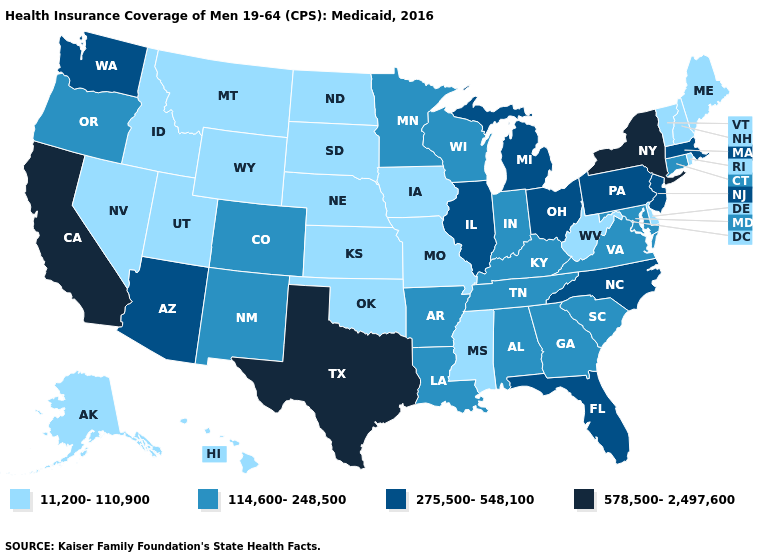What is the highest value in the USA?
Concise answer only. 578,500-2,497,600. Name the states that have a value in the range 11,200-110,900?
Answer briefly. Alaska, Delaware, Hawaii, Idaho, Iowa, Kansas, Maine, Mississippi, Missouri, Montana, Nebraska, Nevada, New Hampshire, North Dakota, Oklahoma, Rhode Island, South Dakota, Utah, Vermont, West Virginia, Wyoming. Which states have the highest value in the USA?
Quick response, please. California, New York, Texas. Does Montana have the same value as Alabama?
Be succinct. No. Does the map have missing data?
Short answer required. No. Which states have the lowest value in the USA?
Keep it brief. Alaska, Delaware, Hawaii, Idaho, Iowa, Kansas, Maine, Mississippi, Missouri, Montana, Nebraska, Nevada, New Hampshire, North Dakota, Oklahoma, Rhode Island, South Dakota, Utah, Vermont, West Virginia, Wyoming. What is the value of South Carolina?
Keep it brief. 114,600-248,500. Which states have the lowest value in the USA?
Write a very short answer. Alaska, Delaware, Hawaii, Idaho, Iowa, Kansas, Maine, Mississippi, Missouri, Montana, Nebraska, Nevada, New Hampshire, North Dakota, Oklahoma, Rhode Island, South Dakota, Utah, Vermont, West Virginia, Wyoming. What is the value of Maryland?
Write a very short answer. 114,600-248,500. Which states have the lowest value in the USA?
Answer briefly. Alaska, Delaware, Hawaii, Idaho, Iowa, Kansas, Maine, Mississippi, Missouri, Montana, Nebraska, Nevada, New Hampshire, North Dakota, Oklahoma, Rhode Island, South Dakota, Utah, Vermont, West Virginia, Wyoming. Does Ohio have the lowest value in the USA?
Write a very short answer. No. Among the states that border Tennessee , does Mississippi have the lowest value?
Quick response, please. Yes. Name the states that have a value in the range 114,600-248,500?
Be succinct. Alabama, Arkansas, Colorado, Connecticut, Georgia, Indiana, Kentucky, Louisiana, Maryland, Minnesota, New Mexico, Oregon, South Carolina, Tennessee, Virginia, Wisconsin. What is the lowest value in the USA?
Write a very short answer. 11,200-110,900. Does South Dakota have the lowest value in the USA?
Quick response, please. Yes. 